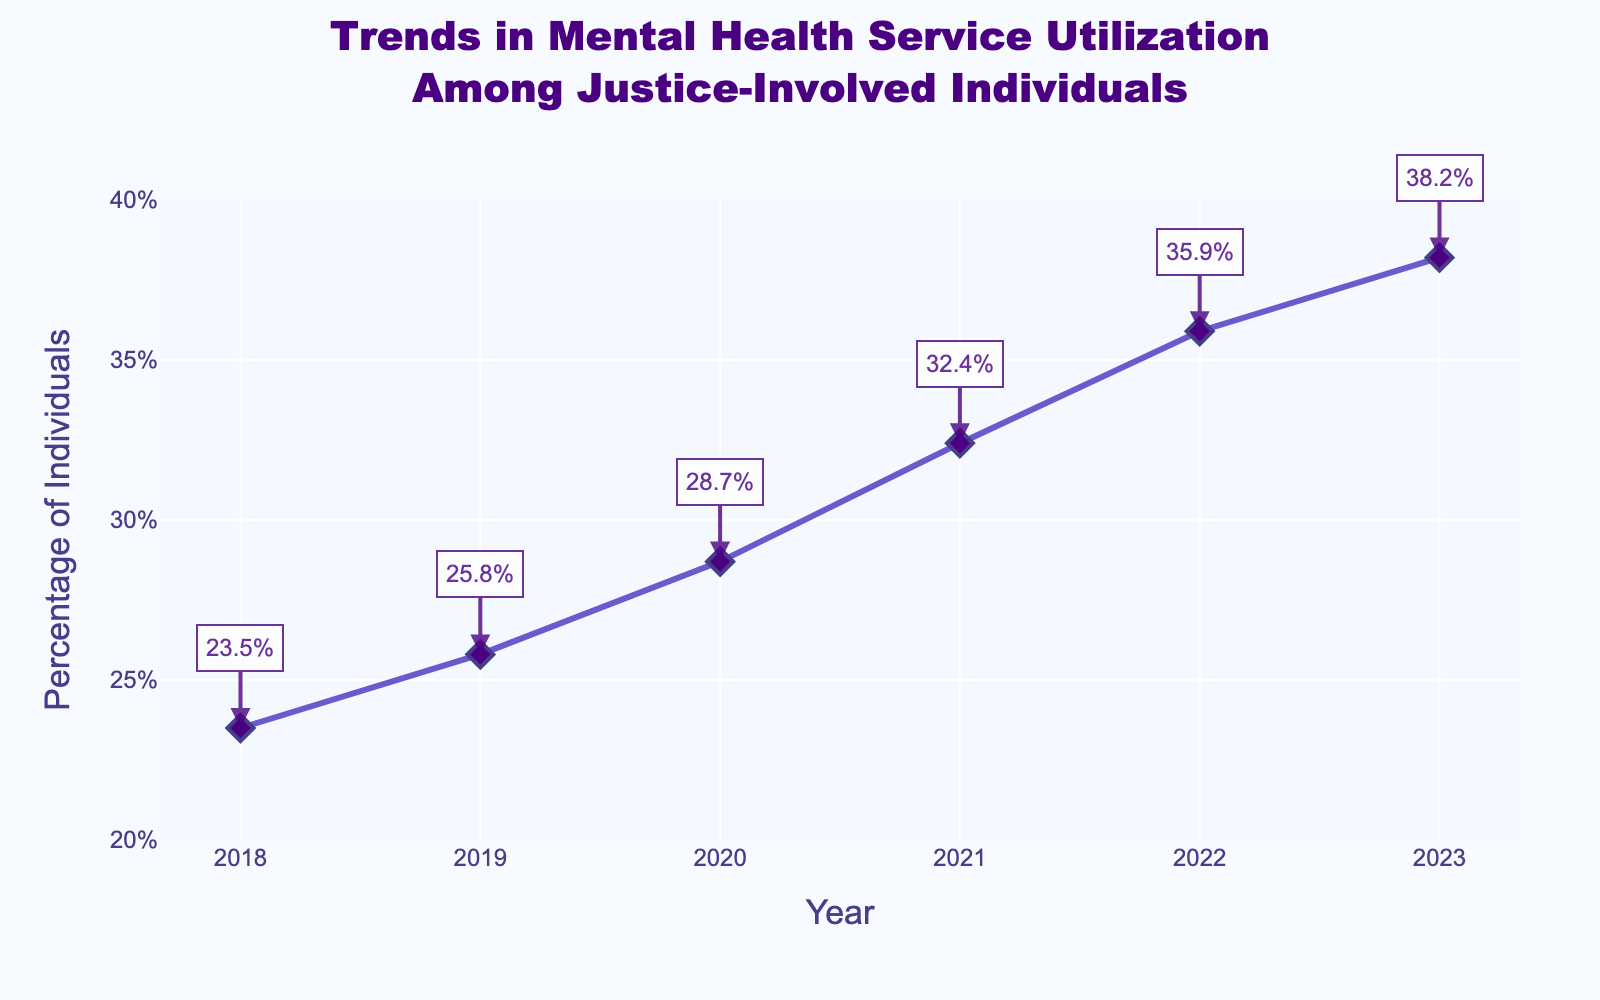What is the percentage increase in mental health service utilization from 2018 to 2023? The percentage in 2018 is 23.5% and in 2023 it is 38.2%. The increase is 38.2% - 23.5% = 14.7%.
Answer: 14.7% What year saw the highest percentage increase in mental health service utilization compared to the previous year? Comparing year-over-year increases: 2018-2019 (25.8% - 23.5% = 2.3%), 2019-2020 (28.7% - 25.8% = 2.9%), 2020-2021 (32.4% - 28.7% = 3.7%), 2021-2022 (35.9% - 32.4% = 3.5%), 2022-2023 (38.2% - 35.9% = 2.3%). The highest increase is from 2020 to 2021.
Answer: 2020-2021 By how much did the utilization percentage increase on average each year between 2018 and 2023? Total increase is 38.2% - 23.5% = 14.7% over 5 years. The average annual increase is 14.7% / 5 = 2.94%.
Answer: 2.94% How does the trend from 2019 to 2020 compare to the trend from 2022 to 2023? The increase from 2019 to 2020 is 28.7% - 25.8% = 2.9%. From 2022 to 2023, it is 38.2% - 35.9% = 2.3%. So it was higher from 2019 to 2020.
Answer: Higher from 2019 to 2020 Which year marks the first time the utilization percentage exceeds 30%? Referring to the percent values on the Y-axis, it exceeds 30% in 2021 with 32.4%.
Answer: 2021 What’s the visual representation color of the line in the graph? The line in the graph is colored purple.
Answer: Purple Between which consecutive years is the smallest increase in the utilization percentage observed? Year-over-year increases are: 2018-2019 (2.3%), 2019-2020 (2.9%), 2020-2021 (3.7%), 2021-2022 (3.5%), 2022-2023 (2.3%). The smallest increase is between 2018 to 2019 and 2022 to 2023, both by 2.3%.
Answer: 2018-2019, 2022-2023 What is the total cumulative percentage increase in mental health service utilization over the entire period from 2018 to 2023? The total percentage change is calculated as the final value minus the initial value: 38.2% - 23.5% = 14.7%.
Answer: 14.7% What percentage of justice-involved individuals used mental health services in 2020? Referring to the graph, the percentage for 2020 is 28.7%.
Answer: 28.7% 